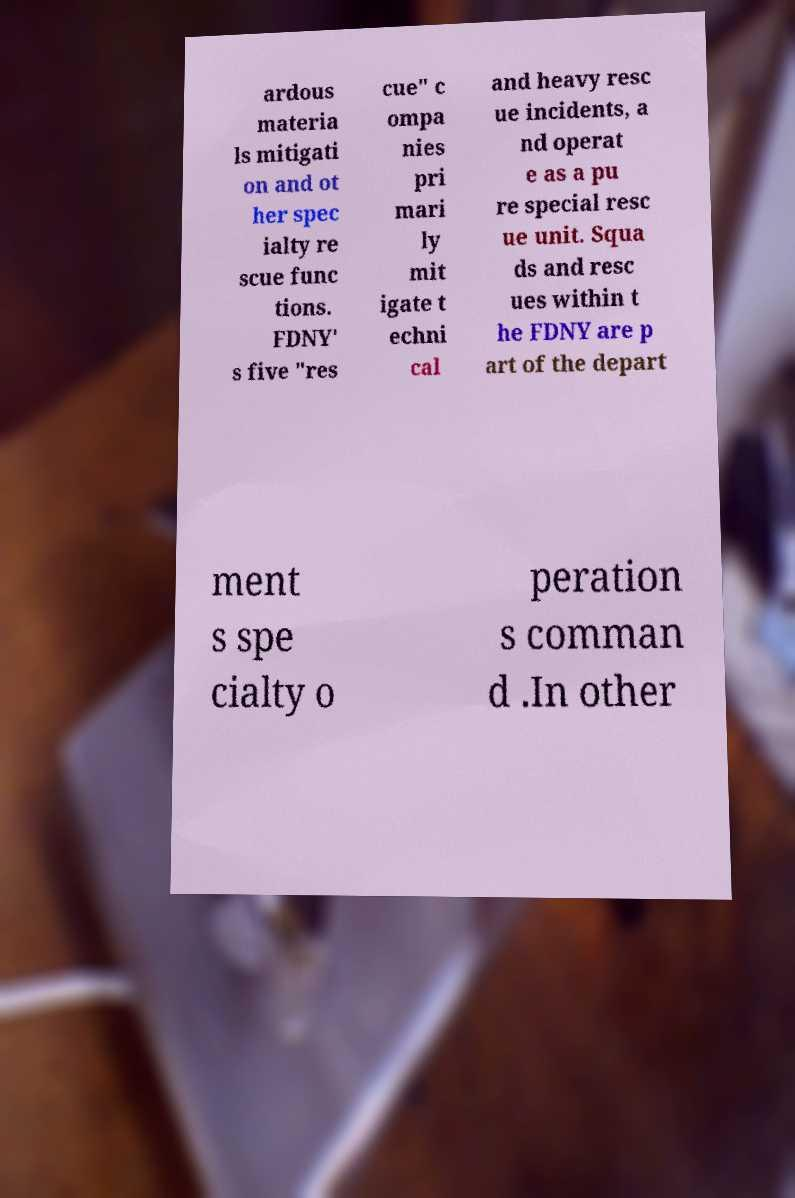Can you accurately transcribe the text from the provided image for me? ardous materia ls mitigati on and ot her spec ialty re scue func tions. FDNY' s five "res cue" c ompa nies pri mari ly mit igate t echni cal and heavy resc ue incidents, a nd operat e as a pu re special resc ue unit. Squa ds and resc ues within t he FDNY are p art of the depart ment s spe cialty o peration s comman d .In other 